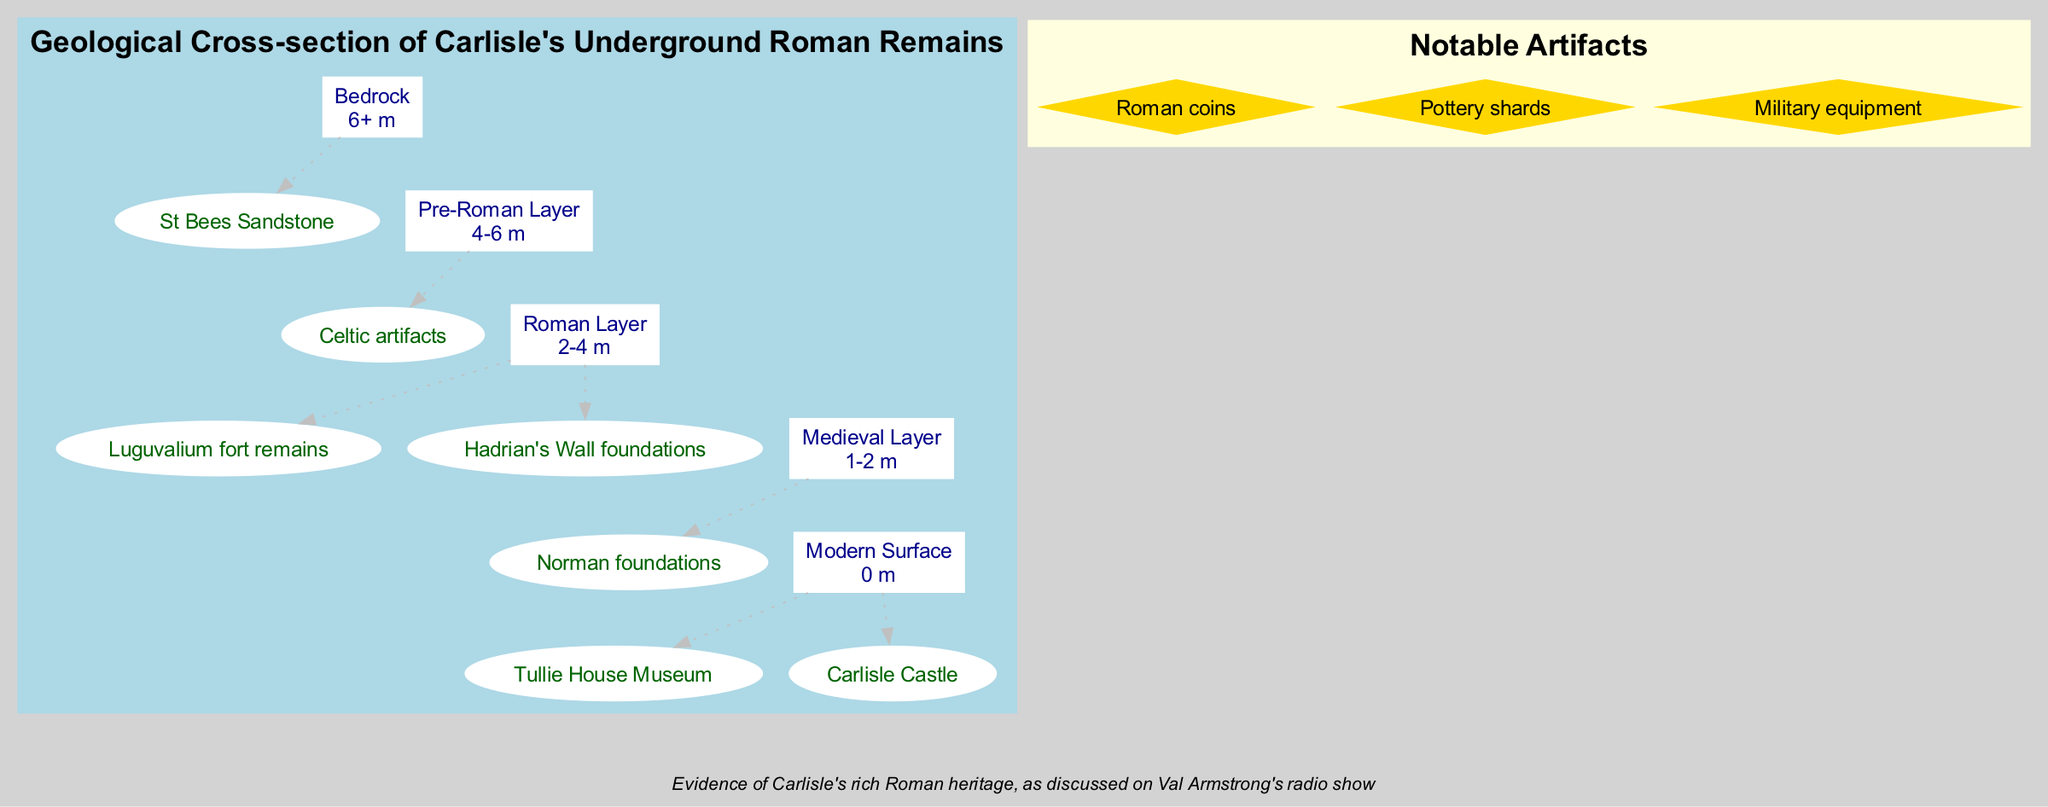What is the top layer in the geological cross-section? The diagram indicates that the top layer is labeled "Modern Surface". This is the most superficial layer and consists of current structures and features in Carlisle.
Answer: Modern Surface How deep is the Roman Layer? The Roman Layer is specifically marked to be between 2 to 4 meters below the surface. This depth defines the boundary where Roman remains can be found.
Answer: 2-4 m What notable artifact is mentioned in the diagram? The diagram lists notable artifacts found in Carlisle, one of which is "Roman coins". This is a specific mention from the artifacts section designed to highlight significant findings.
Answer: Roman coins Which structure is found in the Medieval Layer? The Medieval Layer features "Norman foundations", indicating that this layer contains remnants from the Medieval period that are crucial to historical understanding.
Answer: Norman foundations What lies directly below the Modern Surface? Directly below the Modern Surface, according to the diagram, is the Medieval Layer which ranges from 1 to 2 meters. This indicates a stratigraphic section just beneath contemporary structures.
Answer: Medieval Layer Which layer contains evidence of Carlisle's Roman heritage? The Roman Layer provides evidence of Carlisle's rich Roman heritage, which includes foundational aspects of historical significance, as further discussed in local context shows.
Answer: Roman Layer What is the depth of the Bedrock layer? The Bedrock layer is specified as being 6 meters or deeper. This represents the lowest geological stratum depicted in the diagram.
Answer: 6+ m How many layers are illustrated in this geological cross-section? The diagram illustrates a total of five distinct layers, including Modern Surface, Medieval Layer, Roman Layer, Pre-Roman Layer, and Bedrock. This count includes all specified layers in the diagram.
Answer: 5 Which feature corresponds to the Roman Layer? The Roman Layer contains features such as "Luguvalium fort remains" and "Hadrian's Wall foundations". These signify important Roman constructs in historical geography.
Answer: Luguvalium fort remains, Hadrian's Wall foundations 